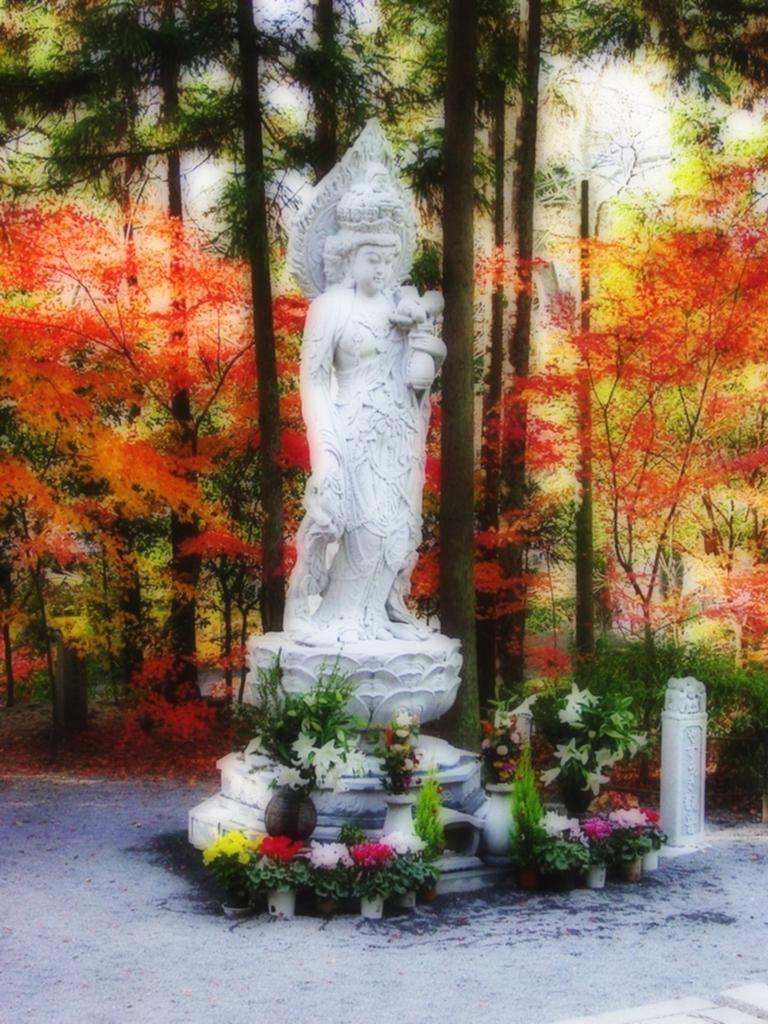What is the main subject in the image? There is a statue in the image. What type of plants can be seen in the image? There are flower plants in the image. What type of vegetation is visible in the image besides flower plants? There are trees in the image. What shape is the invention in the image? There is no invention present in the image, and therefore no shape can be determined. How many spiders can be seen on the statue in the image? There are no spiders present on the statue or in the image. 